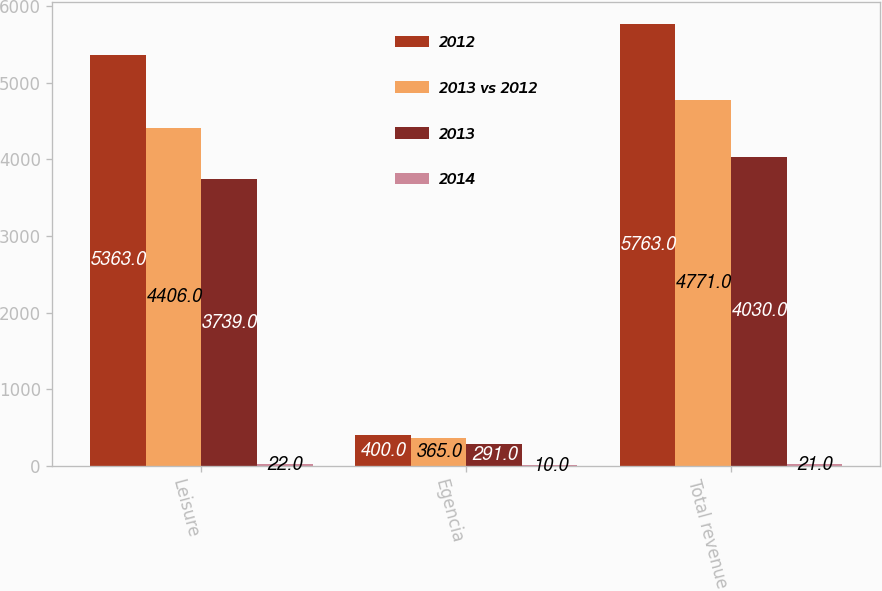Convert chart to OTSL. <chart><loc_0><loc_0><loc_500><loc_500><stacked_bar_chart><ecel><fcel>Leisure<fcel>Egencia<fcel>Total revenue<nl><fcel>2012<fcel>5363<fcel>400<fcel>5763<nl><fcel>2013 vs 2012<fcel>4406<fcel>365<fcel>4771<nl><fcel>2013<fcel>3739<fcel>291<fcel>4030<nl><fcel>2014<fcel>22<fcel>10<fcel>21<nl></chart> 